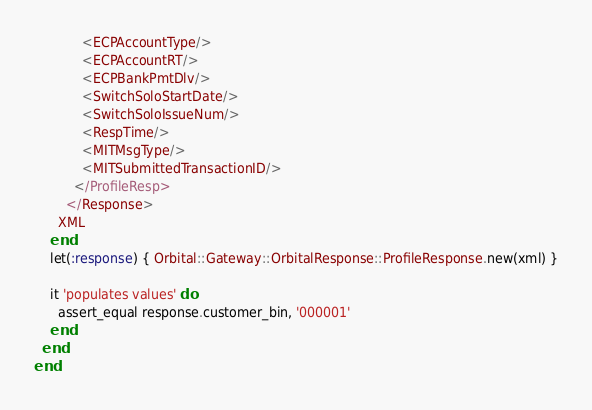Convert code to text. <code><loc_0><loc_0><loc_500><loc_500><_Ruby_>            <ECPAccountType/>
            <ECPAccountRT/>
            <ECPBankPmtDlv/>
            <SwitchSoloStartDate/>
            <SwitchSoloIssueNum/>
            <RespTime/>
            <MITMsgType/>
            <MITSubmittedTransactionID/>
          </ProfileResp>
        </Response>
      XML
    end
    let(:response) { Orbital::Gateway::OrbitalResponse::ProfileResponse.new(xml) }

    it 'populates values' do
      assert_equal response.customer_bin, '000001'
    end
  end
end

</code> 